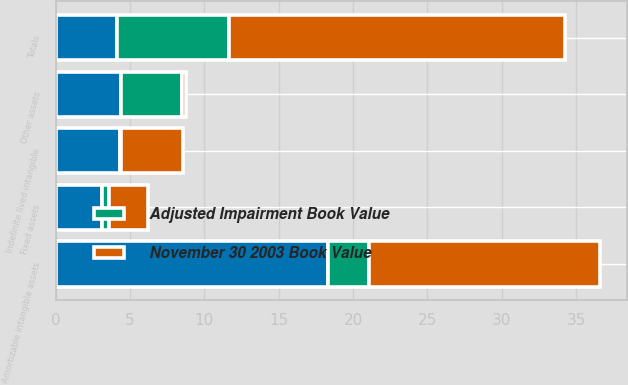Convert chart to OTSL. <chart><loc_0><loc_0><loc_500><loc_500><stacked_bar_chart><ecel><fcel>Amortizable intangible assets<fcel>Indefinite lived intangible<fcel>Fixed assets<fcel>Other assets<fcel>Totals<nl><fcel>nan<fcel>18.3<fcel>4.3<fcel>3.1<fcel>4.4<fcel>4.15<nl><fcel>November 30 2003 Book Value<fcel>15.5<fcel>4.2<fcel>2.6<fcel>0.3<fcel>22.6<nl><fcel>Adjusted Impairment Book Value<fcel>2.8<fcel>0.1<fcel>0.5<fcel>4.1<fcel>7.5<nl></chart> 